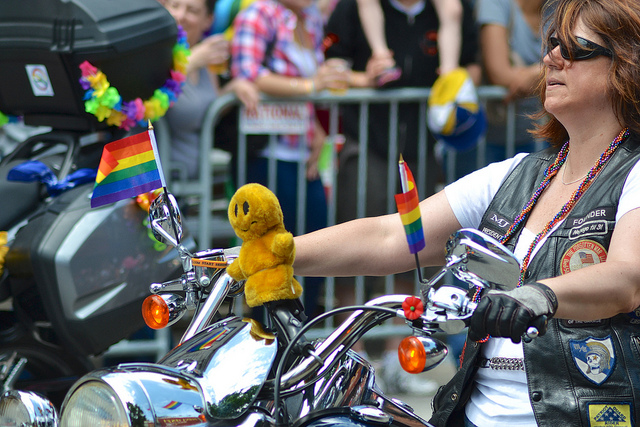Read and extract the text from this image. FOUNDER MJ 8 